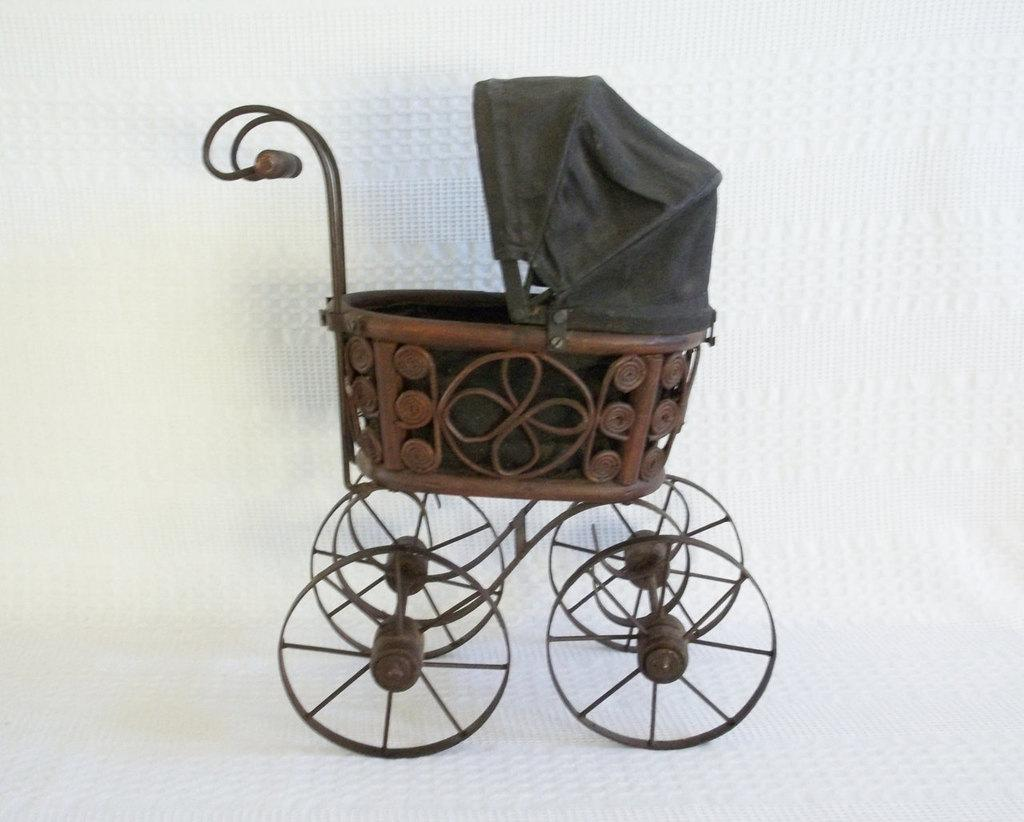What type of object is in the image? There is a vintage doll carriage in the image. Can you describe the surface on which the doll carriage is placed? The doll carriage is present on a surface, but the specific type of surface is not mentioned in the facts. What might the doll carriage be used for? The vintage doll carriage might be used for transporting dolls or other toys. What type of minister is depicted in the image? There is no minister present in the image; it features a vintage doll carriage. How many cups are visible in the image? There is no mention of cups in the facts, so we cannot determine the number of cups present in the image. 